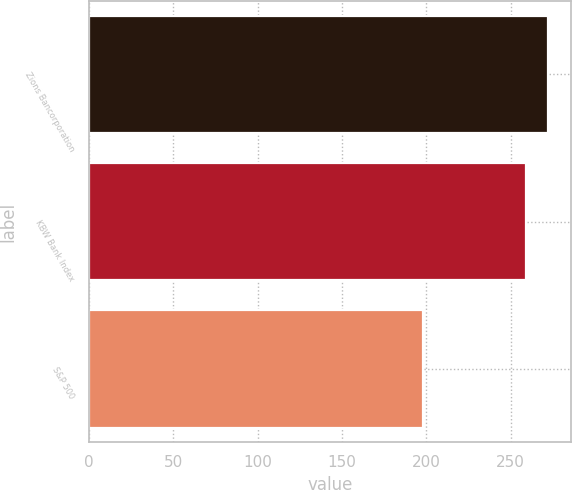Convert chart. <chart><loc_0><loc_0><loc_500><loc_500><bar_chart><fcel>Zions Bancorporation<fcel>KBW Bank Index<fcel>S&P 500<nl><fcel>272.3<fcel>258.8<fcel>198.1<nl></chart> 